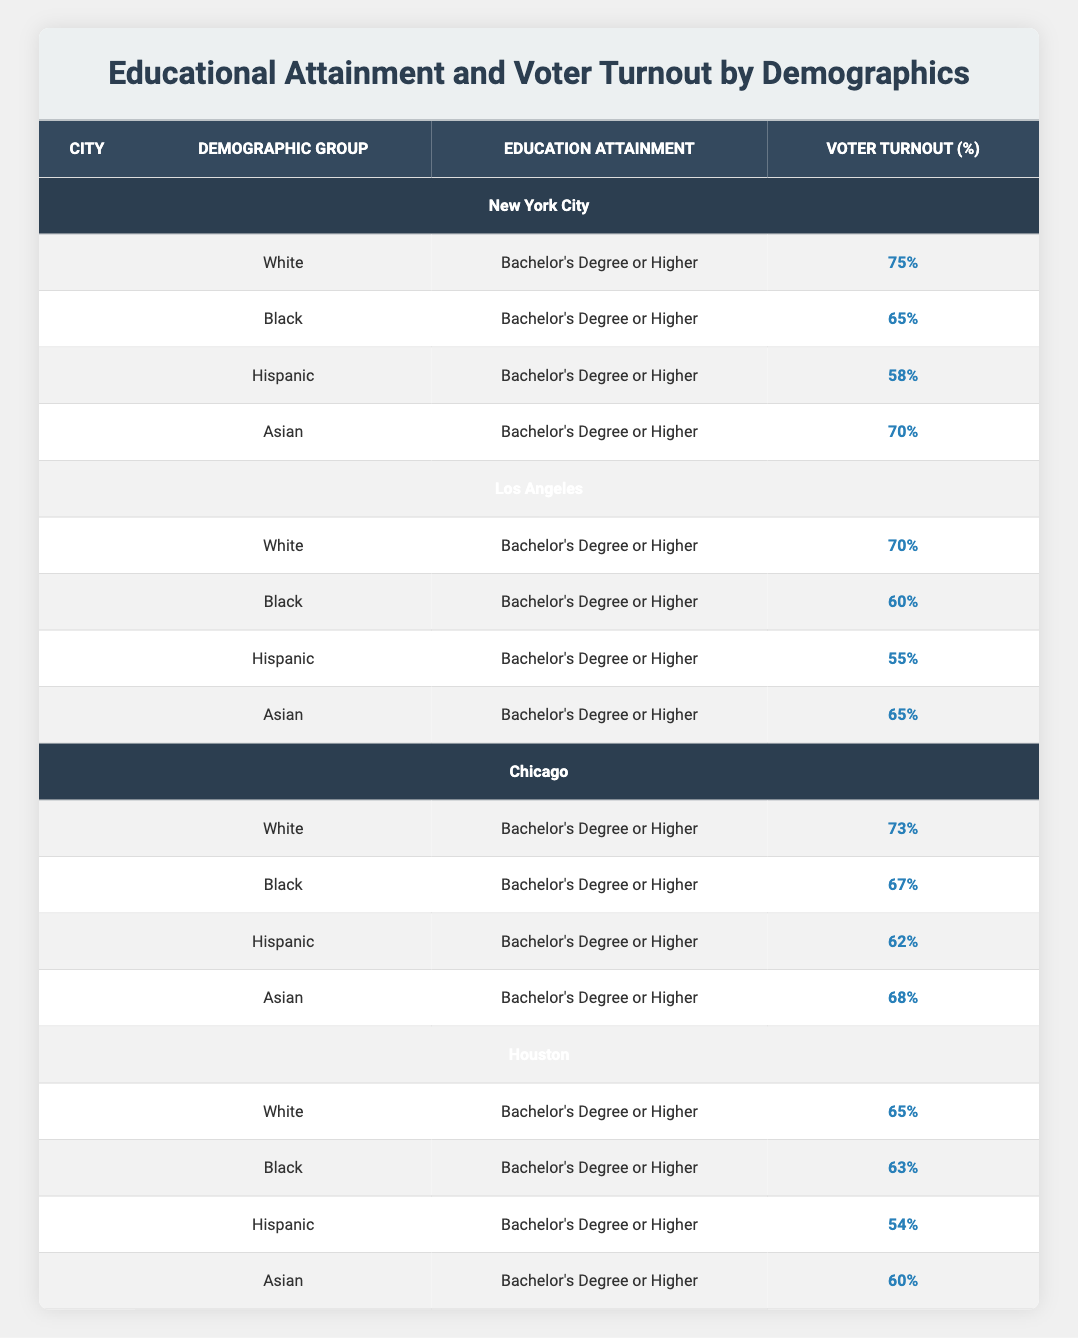What is the voter turnout percentage for the White demographic group in New York City? According to the table, the voter turnout percentage for the White demographic group in New York City is listed as 75%.
Answer: 75% What is the voter turnout percentage for the Hispanic demographic group across all cities? The voter turnout percentage for the Hispanic demographic group in the cities are as follows: New York City 58%, Los Angeles 55%, Chicago 62%, and Houston 54%. The average is calculated as (58 + 55 + 62 + 54) / 4 = 57.25%.
Answer: 57.25% Is the voter turnout percentage for the Asian demographic group higher in Chicago than in Los Angeles? In the table, the voter turnout percentage for Asians is 68% in Chicago and 65% in Los Angeles. Since 68% is greater than 65%, the statement is true.
Answer: Yes Which demographic group has the highest voter turnout percentage in Houston? The demographic groups in Houston have the following turnout percentages: White 65%, Black 63%, Hispanic 54%, and Asian 60%. The highest percentage among these is 65%, which belongs to the White demographic group.
Answer: White How does the average voter turnout for the Black demographic group in all cities compare to the overall average voter turnout across all groups? The voter turnout percentages for Black demographic groups in each city are: New York City 65%, Los Angeles 60%, Chicago 67%, and Houston 63%. The average for Black is calculated as (65 + 60 + 67 + 63) / 4 = 63.75%. For an overall average, we can sum the turnout percentages for each group in all cities (75 + 65 + 58 + 70 + 70 + 60 + 55 + 65 + 73 + 67 + 62 + 68 + 65 + 63 + 54 + 60) and divide by the total number of demographics (16). The total turnout sums up to 1,050 and dividing that total by 16 gives an average turnout of 65.625%. Comparing, the Black demographic average is 63.75%, which is lower than the overall average of 65.625%.
Answer: The average for Black is lower Which city has the lowest voter turnout percentage for the Hispanic demographic group? The table lists the voter turnout percentages for the Hispanic demographic group: New York City 58%, Los Angeles 55%, Chicago 62%, and Houston 54%. The lowest percentage is found in Houston at 54%.
Answer: Houston 